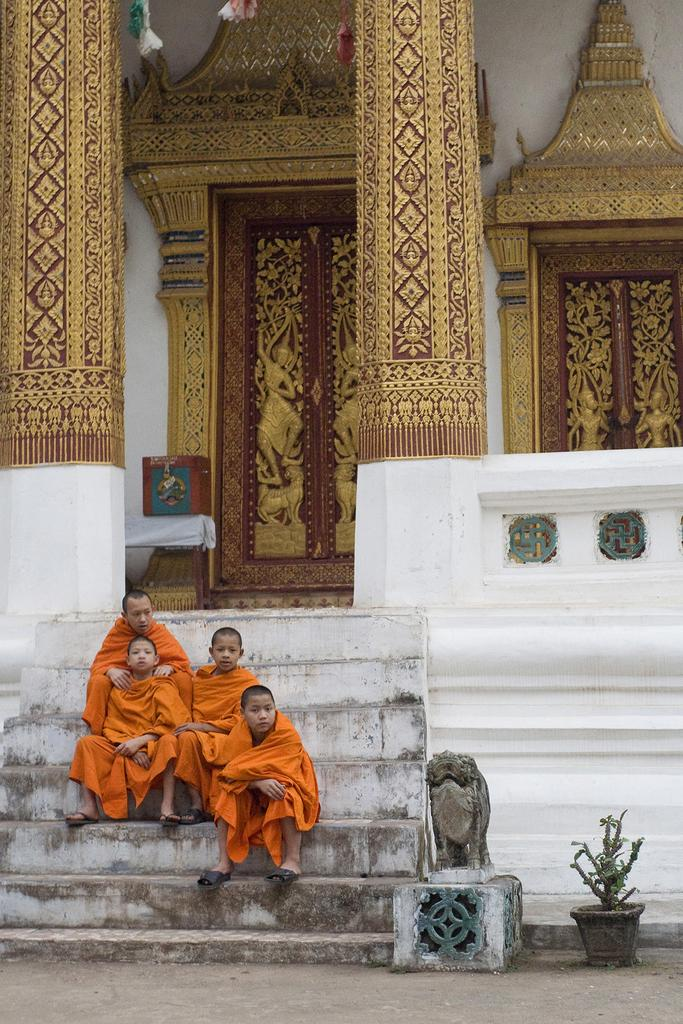What are the people in the image doing? The people in the image are sitting on steps. What is located beside the steps? There is a statue beside the steps. Can you describe any indoor plants in the image? There is a house plant in the image. What architectural features can be seen in the background of the image? In the background, there are pillars, a wall, doors, and a box. What type of curtain is hanging from the north side of the wall in the image? There is no curtain present in the image, and the direction "north" is not mentioned in the provided facts. Can you hear a bell ringing in the image? There is no mention of a bell in the provided facts, so it cannot be determined if one is present or ringing. 